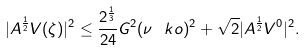Convert formula to latex. <formula><loc_0><loc_0><loc_500><loc_500>| A ^ { \frac { 1 } { 2 } } V ( \zeta ) | ^ { 2 } \leq \frac { 2 ^ { \frac { 1 } { 3 } } } { 2 4 } G ^ { 2 } ( \nu \ k o ) ^ { 2 } + \sqrt { 2 } | A ^ { \frac { 1 } { 2 } } V ^ { 0 } | ^ { 2 } .</formula> 